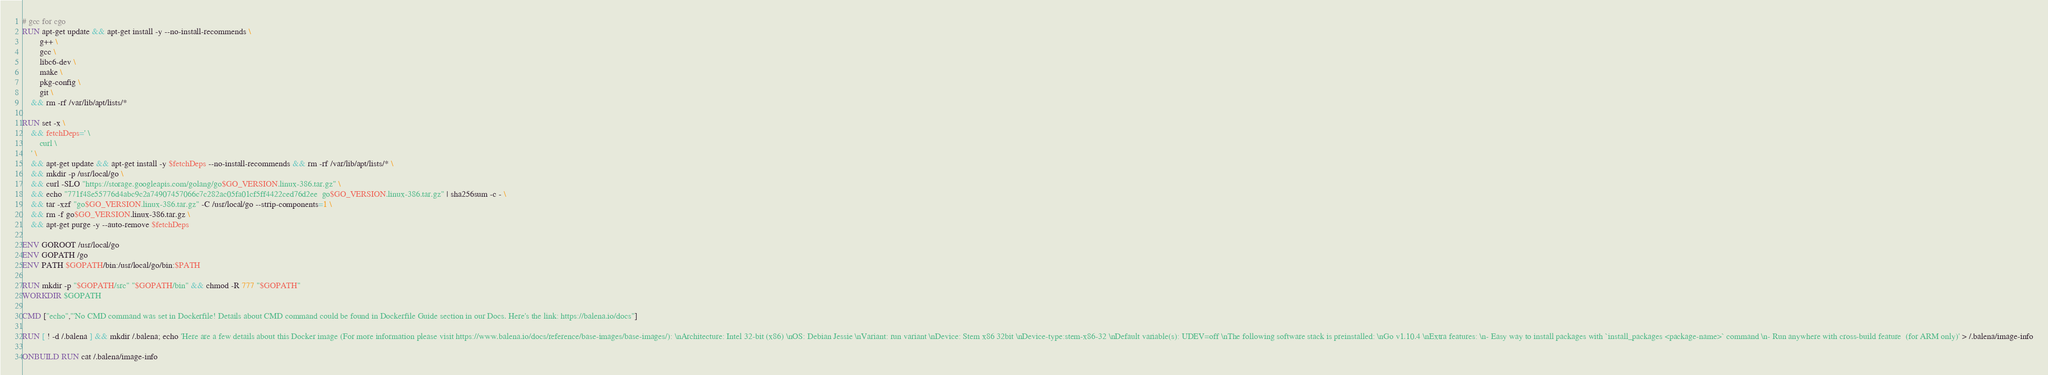Convert code to text. <code><loc_0><loc_0><loc_500><loc_500><_Dockerfile_>
# gcc for cgo
RUN apt-get update && apt-get install -y --no-install-recommends \
		g++ \
		gcc \
		libc6-dev \
		make \
		pkg-config \
		git \
	&& rm -rf /var/lib/apt/lists/*

RUN set -x \
	&& fetchDeps=' \
		curl \
	' \
	&& apt-get update && apt-get install -y $fetchDeps --no-install-recommends && rm -rf /var/lib/apt/lists/* \
	&& mkdir -p /usr/local/go \
	&& curl -SLO "https://storage.googleapis.com/golang/go$GO_VERSION.linux-386.tar.gz" \
	&& echo "771f48e55776d4abc9c2a74907457066c7c282ac05fa01cf5ff4422ced76d2ee  go$GO_VERSION.linux-386.tar.gz" | sha256sum -c - \
	&& tar -xzf "go$GO_VERSION.linux-386.tar.gz" -C /usr/local/go --strip-components=1 \
	&& rm -f go$GO_VERSION.linux-386.tar.gz \
	&& apt-get purge -y --auto-remove $fetchDeps

ENV GOROOT /usr/local/go
ENV GOPATH /go
ENV PATH $GOPATH/bin:/usr/local/go/bin:$PATH

RUN mkdir -p "$GOPATH/src" "$GOPATH/bin" && chmod -R 777 "$GOPATH"
WORKDIR $GOPATH

CMD ["echo","'No CMD command was set in Dockerfile! Details about CMD command could be found in Dockerfile Guide section in our Docs. Here's the link: https://balena.io/docs"]

RUN [ ! -d /.balena ] && mkdir /.balena; echo 'Here are a few details about this Docker image (For more information please visit https://www.balena.io/docs/reference/base-images/base-images/): \nArchitecture: Intel 32-bit (x86) \nOS: Debian Jessie \nVariant: run variant \nDevice: Stem x86 32bit \nDevice-type:stem-x86-32 \nDefault variable(s): UDEV=off \nThe following software stack is preinstalled: \nGo v1.10.4 \nExtra features: \n- Easy way to install packages with `install_packages <package-name>` command \n- Run anywhere with cross-build feature  (for ARM only)' > /.balena/image-info

ONBUILD RUN cat /.balena/image-info</code> 